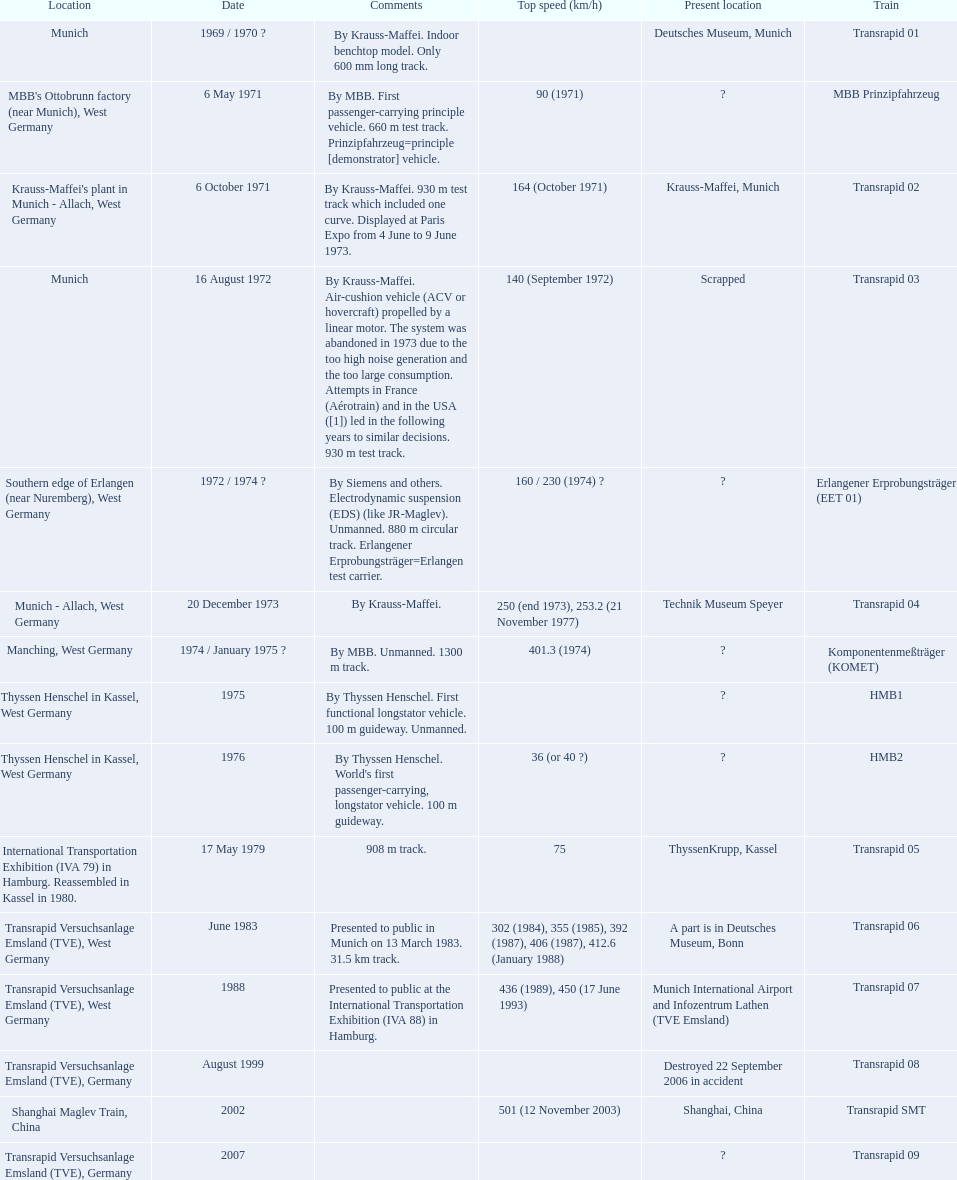What are all trains? Transrapid 01, MBB Prinzipfahrzeug, Transrapid 02, Transrapid 03, Erlangener Erprobungsträger (EET 01), Transrapid 04, Komponentenmeßträger (KOMET), HMB1, HMB2, Transrapid 05, Transrapid 06, Transrapid 07, Transrapid 08, Transrapid SMT, Transrapid 09. Which of all location of trains are known? Deutsches Museum, Munich, Krauss-Maffei, Munich, Scrapped, Technik Museum Speyer, ThyssenKrupp, Kassel, A part is in Deutsches Museum, Bonn, Munich International Airport and Infozentrum Lathen (TVE Emsland), Destroyed 22 September 2006 in accident, Shanghai, China. Which of those trains were scrapped? Transrapid 03. 